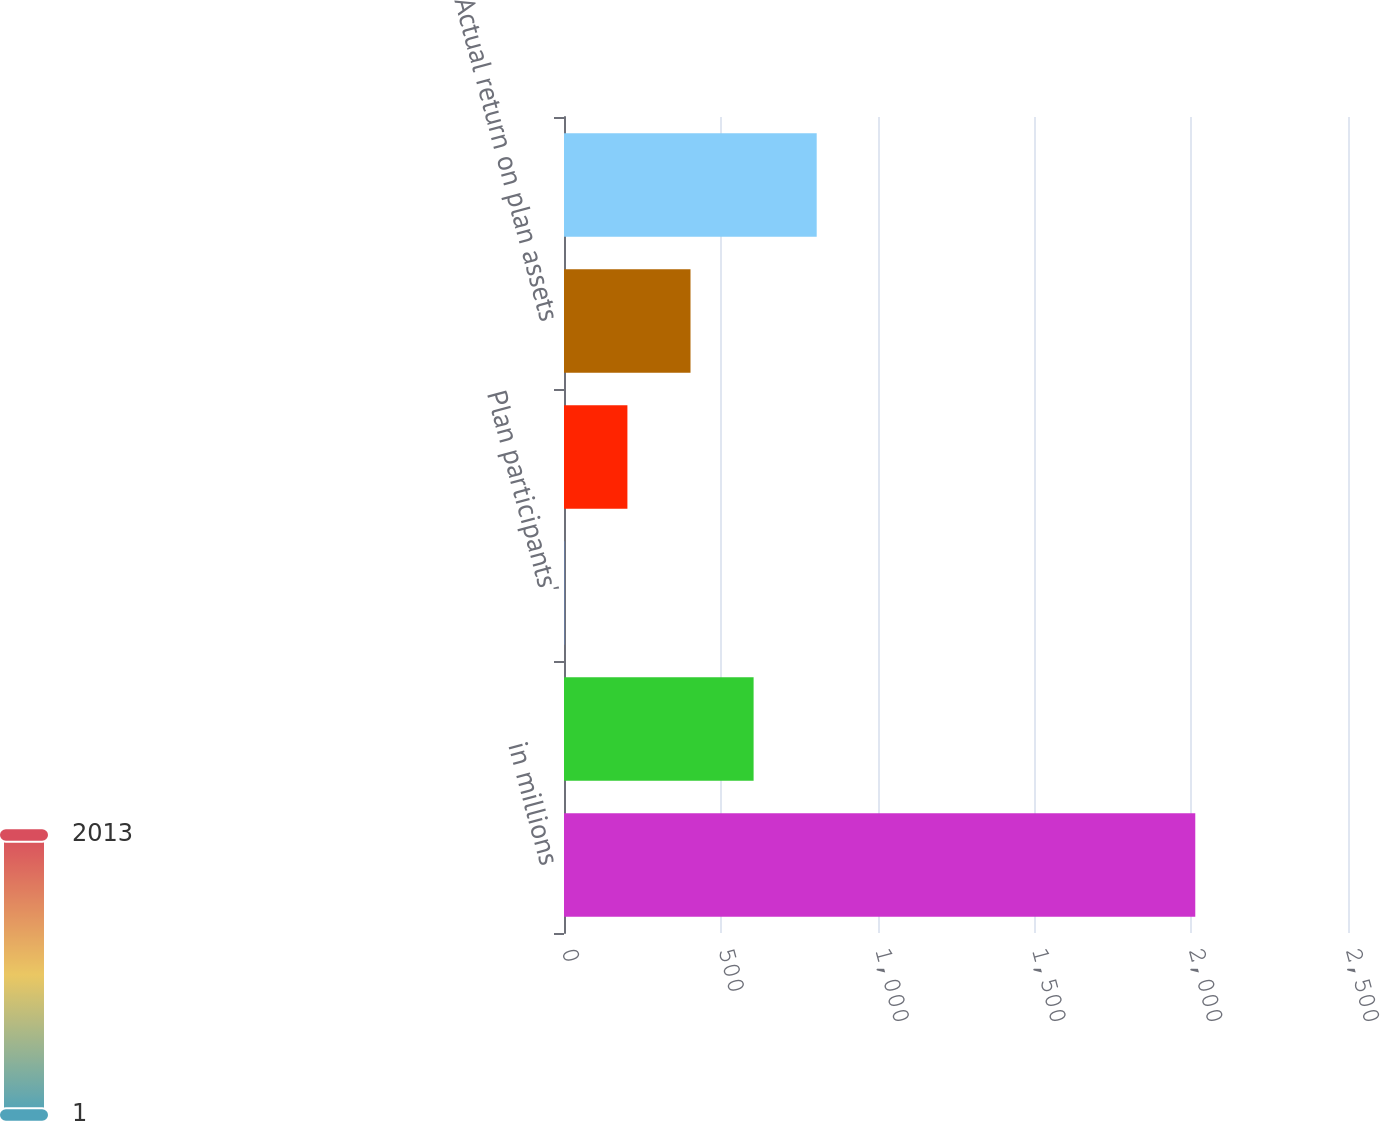<chart> <loc_0><loc_0><loc_500><loc_500><bar_chart><fcel>in millions<fcel>FVA at beginning of year<fcel>Plan participants'<fcel>Benefit payments<fcel>Actual return on plan assets<fcel>FVA at end of year<nl><fcel>2013<fcel>604.6<fcel>1<fcel>202.2<fcel>403.4<fcel>805.8<nl></chart> 